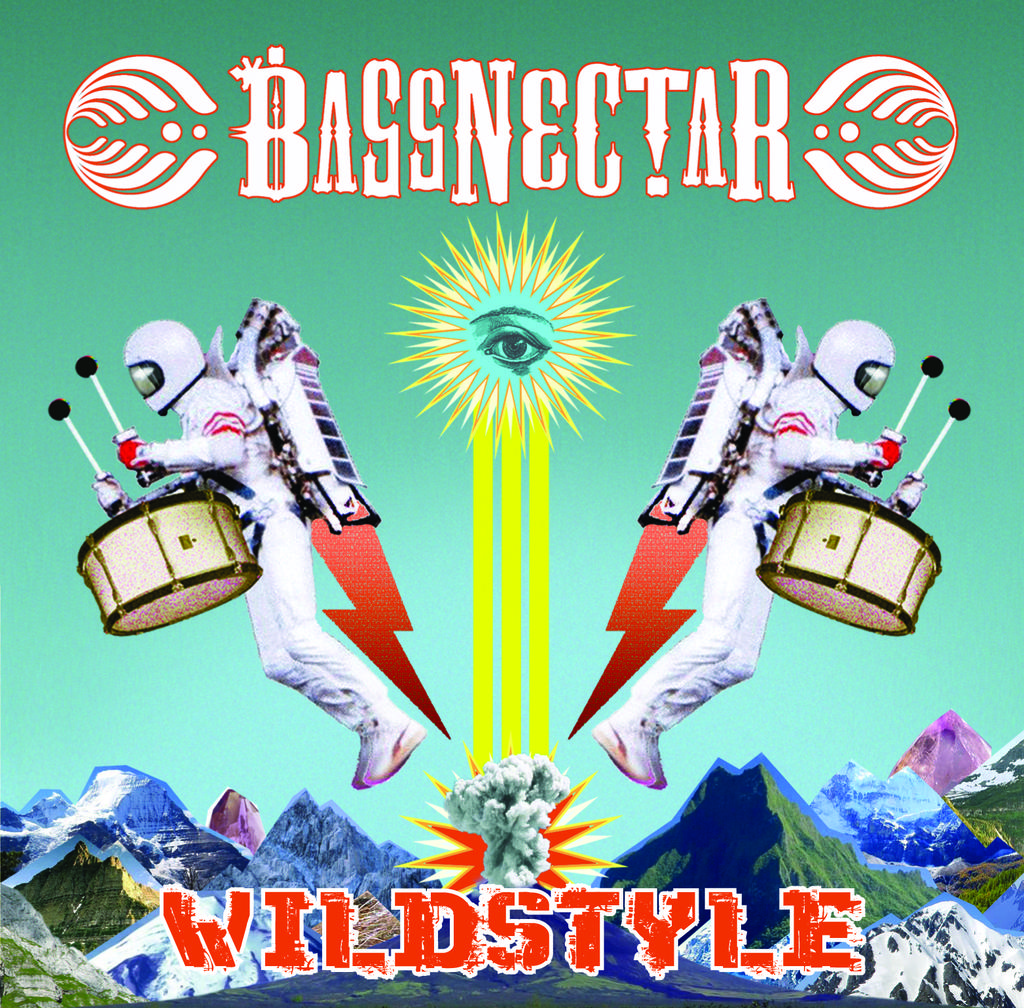What type of visual is the image? The image is a poster. How many people are depicted in the poster? There are two people in the poster. What objects are present in the poster? There are drumsticks and some objects in the poster. What natural feature can be seen in the poster? There are mountains in the poster. What else is present in the poster besides the people and objects? There is smoke in the poster. Is there any text in the poster? Yes, there is text in the poster. What type of cable is being used by the representative in the poster? There is no representative or cable present in the poster. What tool is the wrench being used for in the poster? There is no wrench present in the poster. 